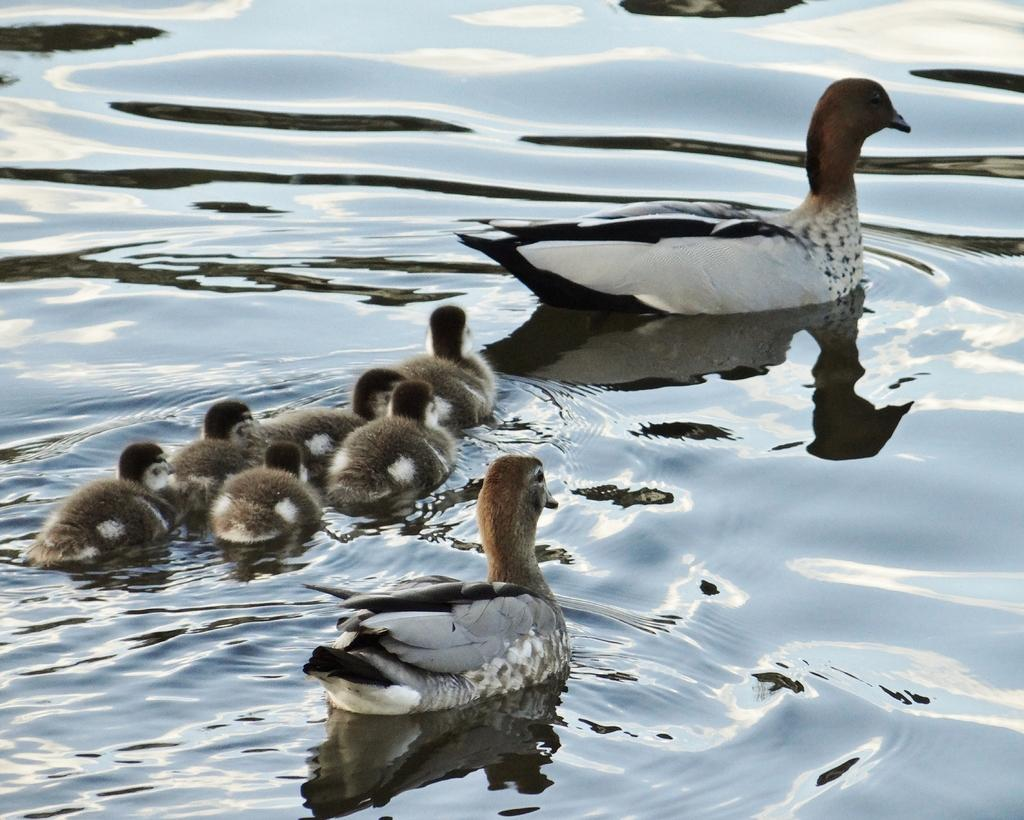What type of animals are in the image? There are ducks in the image. Where are the ducks located? The ducks are on the water. What type of behavior is the celery exhibiting during the protest in the image? There is no celery or protest present in the image; it features ducks on the water. 